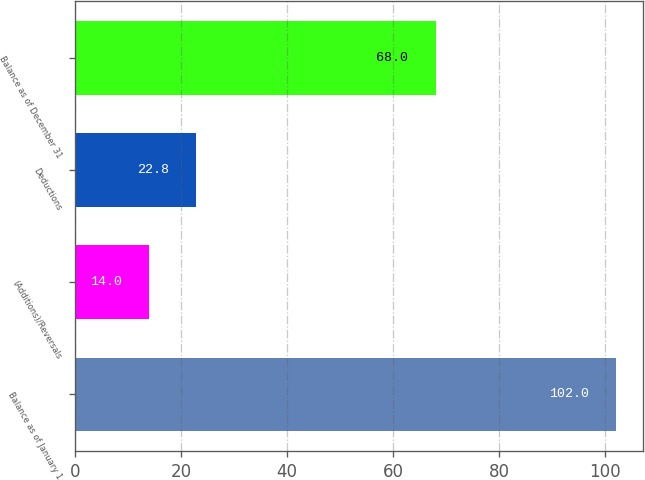<chart> <loc_0><loc_0><loc_500><loc_500><bar_chart><fcel>Balance as of January 1<fcel>(Additions)/Reversals<fcel>Deductions<fcel>Balance as of December 31<nl><fcel>102<fcel>14<fcel>22.8<fcel>68<nl></chart> 